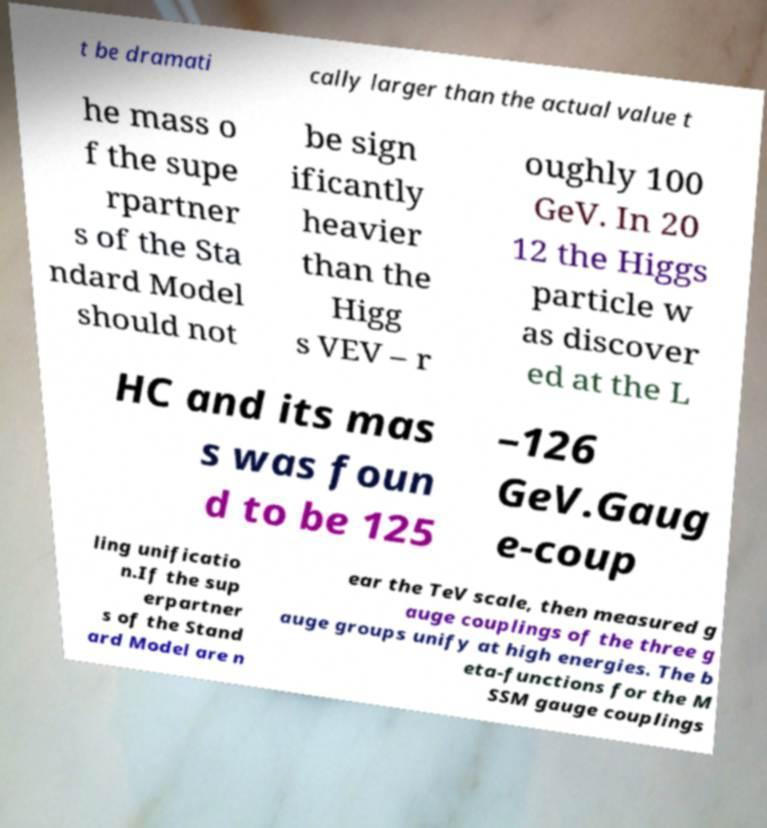Please read and relay the text visible in this image. What does it say? t be dramati cally larger than the actual value t he mass o f the supe rpartner s of the Sta ndard Model should not be sign ificantly heavier than the Higg s VEV – r oughly 100 GeV. In 20 12 the Higgs particle w as discover ed at the L HC and its mas s was foun d to be 125 –126 GeV.Gaug e-coup ling unificatio n.If the sup erpartner s of the Stand ard Model are n ear the TeV scale, then measured g auge couplings of the three g auge groups unify at high energies. The b eta-functions for the M SSM gauge couplings 